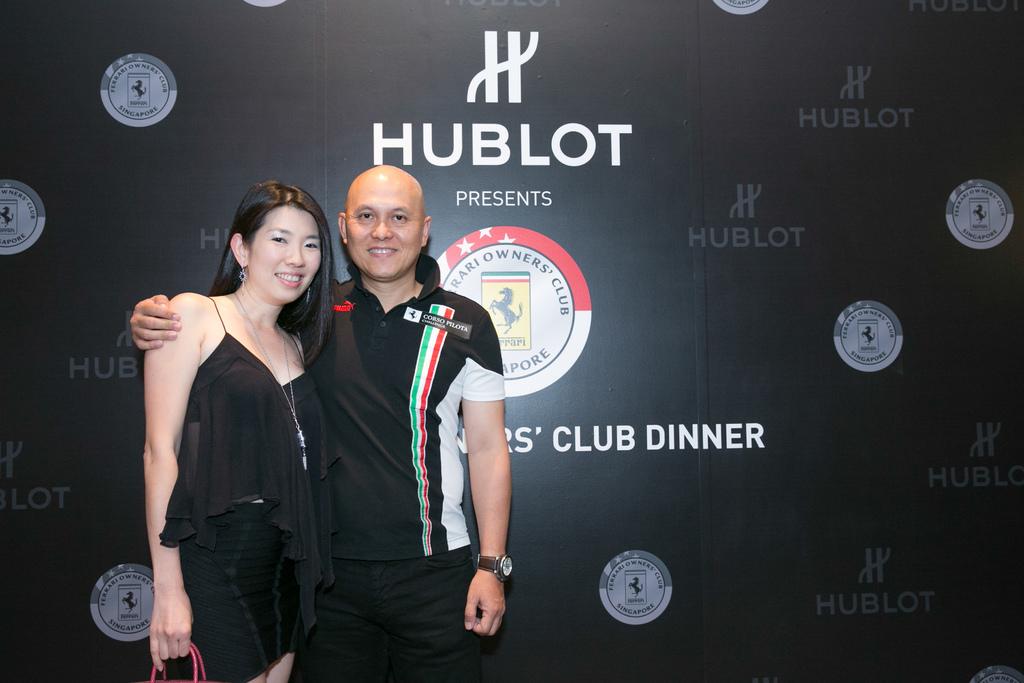Who is sponsoring the event?
Keep it short and to the point. Hublot. 